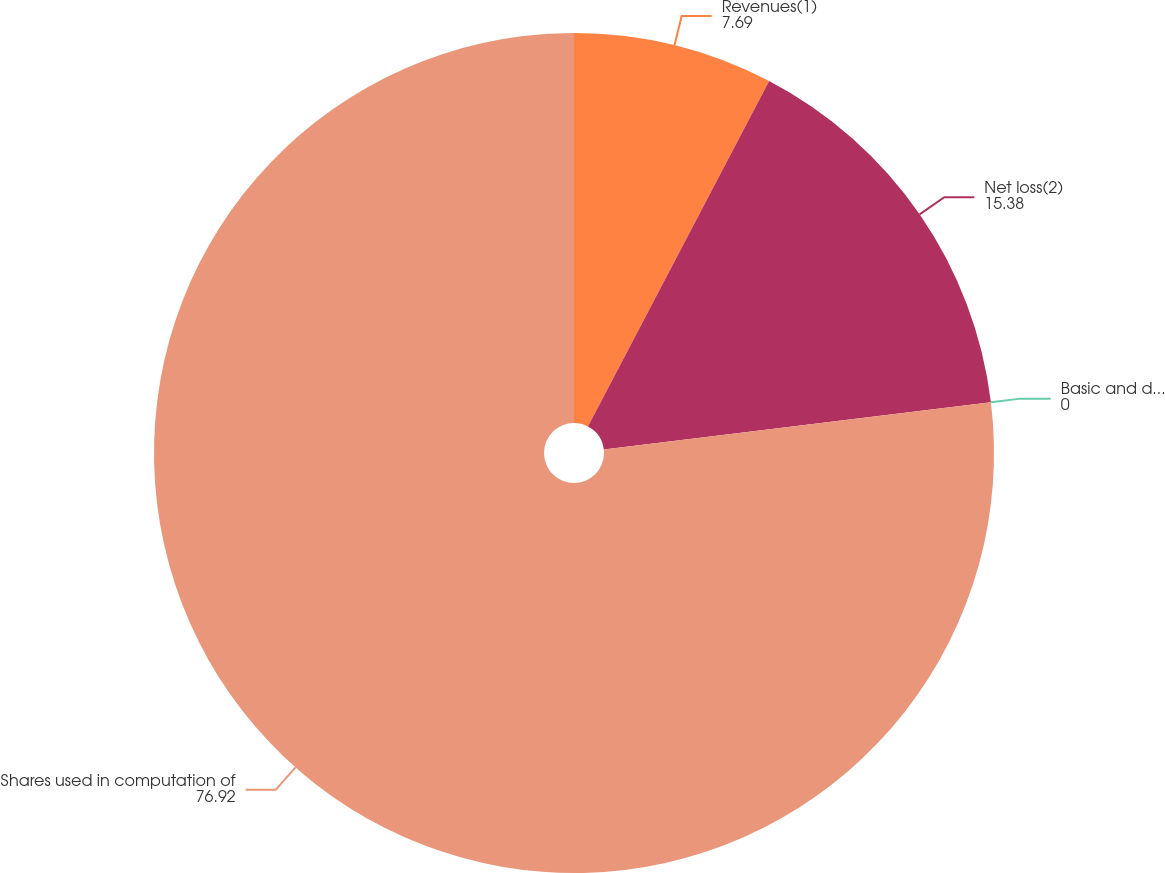Convert chart to OTSL. <chart><loc_0><loc_0><loc_500><loc_500><pie_chart><fcel>Revenues(1)<fcel>Net loss(2)<fcel>Basic and diluted net loss per<fcel>Shares used in computation of<nl><fcel>7.69%<fcel>15.38%<fcel>0.0%<fcel>76.92%<nl></chart> 